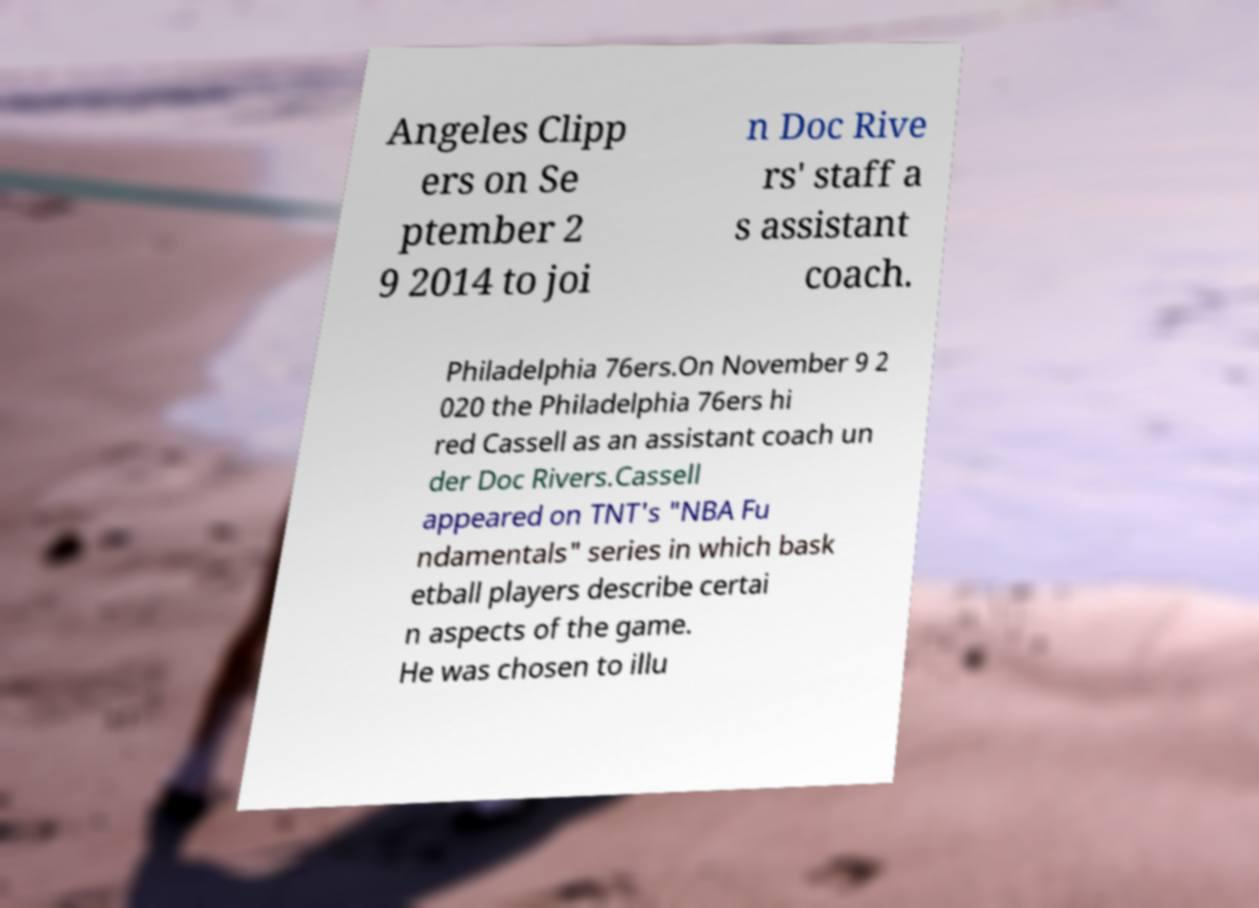Please read and relay the text visible in this image. What does it say? Angeles Clipp ers on Se ptember 2 9 2014 to joi n Doc Rive rs' staff a s assistant coach. Philadelphia 76ers.On November 9 2 020 the Philadelphia 76ers hi red Cassell as an assistant coach un der Doc Rivers.Cassell appeared on TNT's "NBA Fu ndamentals" series in which bask etball players describe certai n aspects of the game. He was chosen to illu 